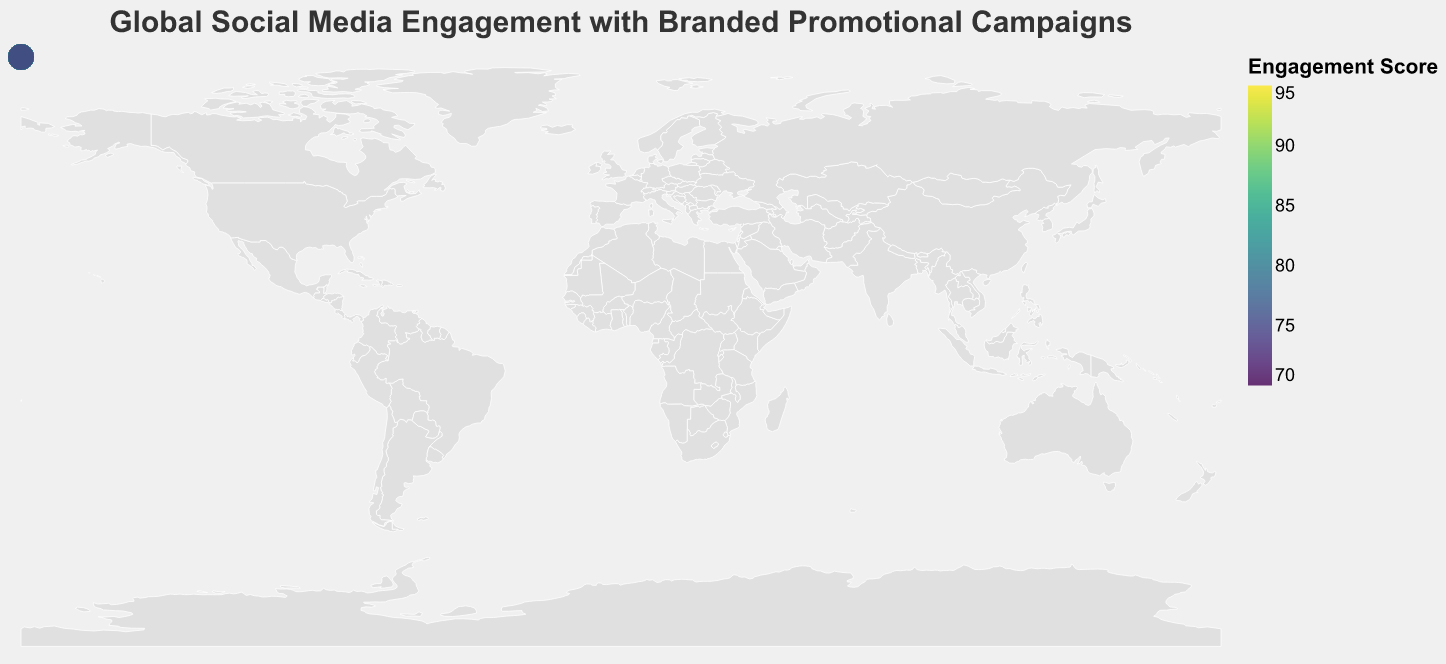What is the highest social media engagement score shown on the map? The global heat map shows the engagement score values for different countries. The highest score visible is in China.
Answer: 92 Which region has the lowest social media engagement score? Africa has the lowest social media engagement score. By locating South Africa on the map, we note it has a score of 71.
Answer: Africa How does the social media engagement score of the United States compare to that of Canada? The map shows that the United States has an engagement score of 87, while Canada has a score of 82. Comparing these, the United States has a higher score than Canada.
Answer: United States has a higher score What is the average engagement score of countries in Europe? The European countries listed are the United Kingdom (85), Germany (81), France (80), Russia (73), Italy (79), Spain (78), and the Netherlands (82). Adding these scores and dividing by the number of countries gives the average (85+81+80+73+79+78+82)/7 = 79.71.
Answer: 79.71 Which countries in Asia appear to have the highest social media engagement scores? By identifying Asian countries and their scores on the map, we see that China has the highest score (92), followed by Singapore (86) and South Korea (84).
Answer: China, Singapore, South Korea Compare the social media engagement score of Australia with that of Indonesia. Which one is higher and by how much? Australia's score is 76, and Indonesia's score is 77. Indonesia's score is higher by 1 point.
Answer: Indonesia by 1 point Is the social media engagement score of Brazil higher or lower than that of Mexico? The map shows Brazil with an engagement score of 83 and Mexico with a score of 75. Therefore, Brazil's score is higher.
Answer: Brazil is higher Across all countries shown on the map, what is the range of social media engagement scores? The highest score on the map is 92 (China) and the lowest is 71 (South Africa). The range is calculated as 92 - 71 = 21.
Answer: 21 What is the median social media engagement score for North America? The North American countries are the United States (87), Canada (82), and Mexico (75). To find the median, sort the scores (75, 82, 87) and the middle value is 82.
Answer: 82 How many countries have a social media engagement score greater than 80? By counting the countries on the map with scores above 80: United States (87), China (92), United Kingdom (85), Germany (81), Canada (82), Singapore (86), South Korea (84), Brazil (83), and Netherlands (82), there are 9 countries.
Answer: 9 